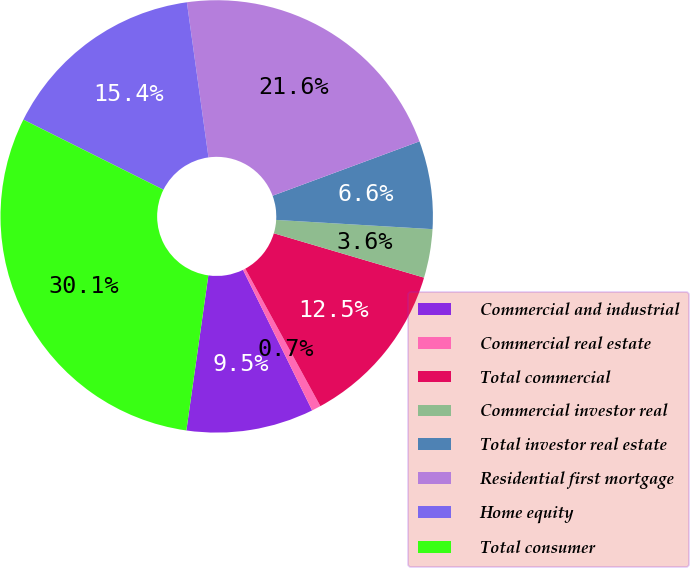Convert chart to OTSL. <chart><loc_0><loc_0><loc_500><loc_500><pie_chart><fcel>Commercial and industrial<fcel>Commercial real estate<fcel>Total commercial<fcel>Commercial investor real<fcel>Total investor real estate<fcel>Residential first mortgage<fcel>Home equity<fcel>Total consumer<nl><fcel>9.52%<fcel>0.68%<fcel>12.47%<fcel>3.63%<fcel>6.58%<fcel>21.56%<fcel>15.41%<fcel>30.14%<nl></chart> 